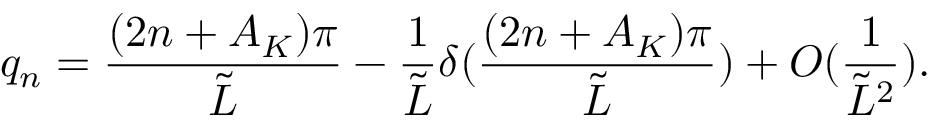Convert formula to latex. <formula><loc_0><loc_0><loc_500><loc_500>q _ { n } = \frac { ( 2 n + A _ { K } ) \pi } { \tilde { L } } - \frac { 1 } { \tilde { L } } \delta ( \frac { ( 2 n + A _ { K } ) \pi } { \tilde { L } } ) + O ( \frac { 1 } { \tilde { L } ^ { 2 } } ) .</formula> 